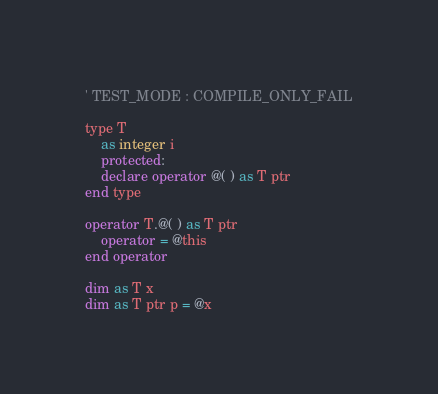<code> <loc_0><loc_0><loc_500><loc_500><_VisualBasic_>' TEST_MODE : COMPILE_ONLY_FAIL

type T
	as integer i
	protected:
	declare operator @( ) as T ptr
end type

operator T.@( ) as T ptr
	operator = @this
end operator

dim as T x
dim as T ptr p = @x
</code> 